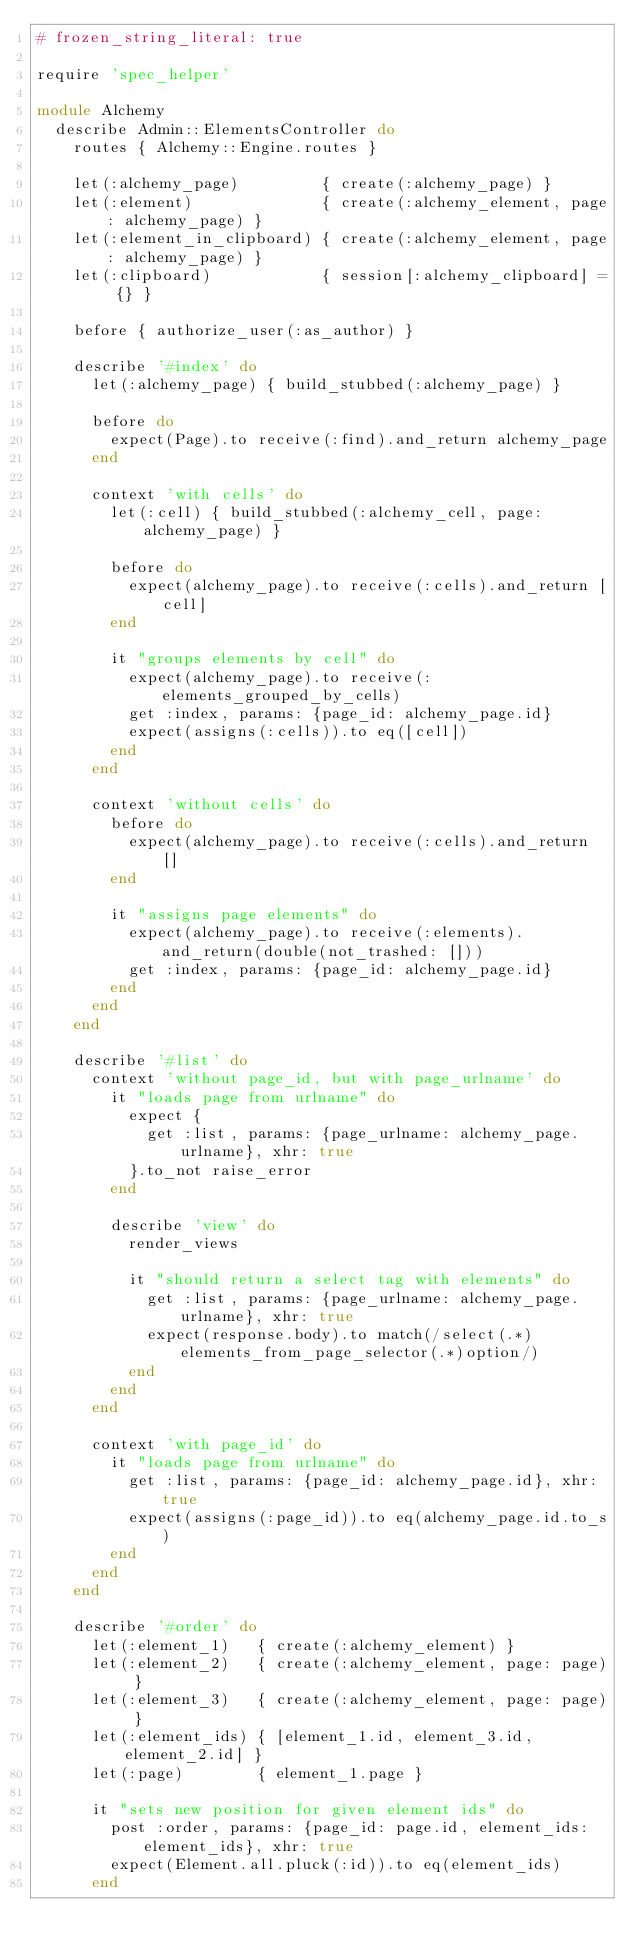Convert code to text. <code><loc_0><loc_0><loc_500><loc_500><_Ruby_># frozen_string_literal: true

require 'spec_helper'

module Alchemy
  describe Admin::ElementsController do
    routes { Alchemy::Engine.routes }

    let(:alchemy_page)         { create(:alchemy_page) }
    let(:element)              { create(:alchemy_element, page: alchemy_page) }
    let(:element_in_clipboard) { create(:alchemy_element, page: alchemy_page) }
    let(:clipboard)            { session[:alchemy_clipboard] = {} }

    before { authorize_user(:as_author) }

    describe '#index' do
      let(:alchemy_page) { build_stubbed(:alchemy_page) }

      before do
        expect(Page).to receive(:find).and_return alchemy_page
      end

      context 'with cells' do
        let(:cell) { build_stubbed(:alchemy_cell, page: alchemy_page) }

        before do
          expect(alchemy_page).to receive(:cells).and_return [cell]
        end

        it "groups elements by cell" do
          expect(alchemy_page).to receive(:elements_grouped_by_cells)
          get :index, params: {page_id: alchemy_page.id}
          expect(assigns(:cells)).to eq([cell])
        end
      end

      context 'without cells' do
        before do
          expect(alchemy_page).to receive(:cells).and_return []
        end

        it "assigns page elements" do
          expect(alchemy_page).to receive(:elements).and_return(double(not_trashed: []))
          get :index, params: {page_id: alchemy_page.id}
        end
      end
    end

    describe '#list' do
      context 'without page_id, but with page_urlname' do
        it "loads page from urlname" do
          expect {
            get :list, params: {page_urlname: alchemy_page.urlname}, xhr: true
          }.to_not raise_error
        end

        describe 'view' do
          render_views

          it "should return a select tag with elements" do
            get :list, params: {page_urlname: alchemy_page.urlname}, xhr: true
            expect(response.body).to match(/select(.*)elements_from_page_selector(.*)option/)
          end
        end
      end

      context 'with page_id' do
        it "loads page from urlname" do
          get :list, params: {page_id: alchemy_page.id}, xhr: true
          expect(assigns(:page_id)).to eq(alchemy_page.id.to_s)
        end
      end
    end

    describe '#order' do
      let(:element_1)   { create(:alchemy_element) }
      let(:element_2)   { create(:alchemy_element, page: page) }
      let(:element_3)   { create(:alchemy_element, page: page) }
      let(:element_ids) { [element_1.id, element_3.id, element_2.id] }
      let(:page)        { element_1.page }

      it "sets new position for given element ids" do
        post :order, params: {page_id: page.id, element_ids: element_ids}, xhr: true
        expect(Element.all.pluck(:id)).to eq(element_ids)
      end
</code> 